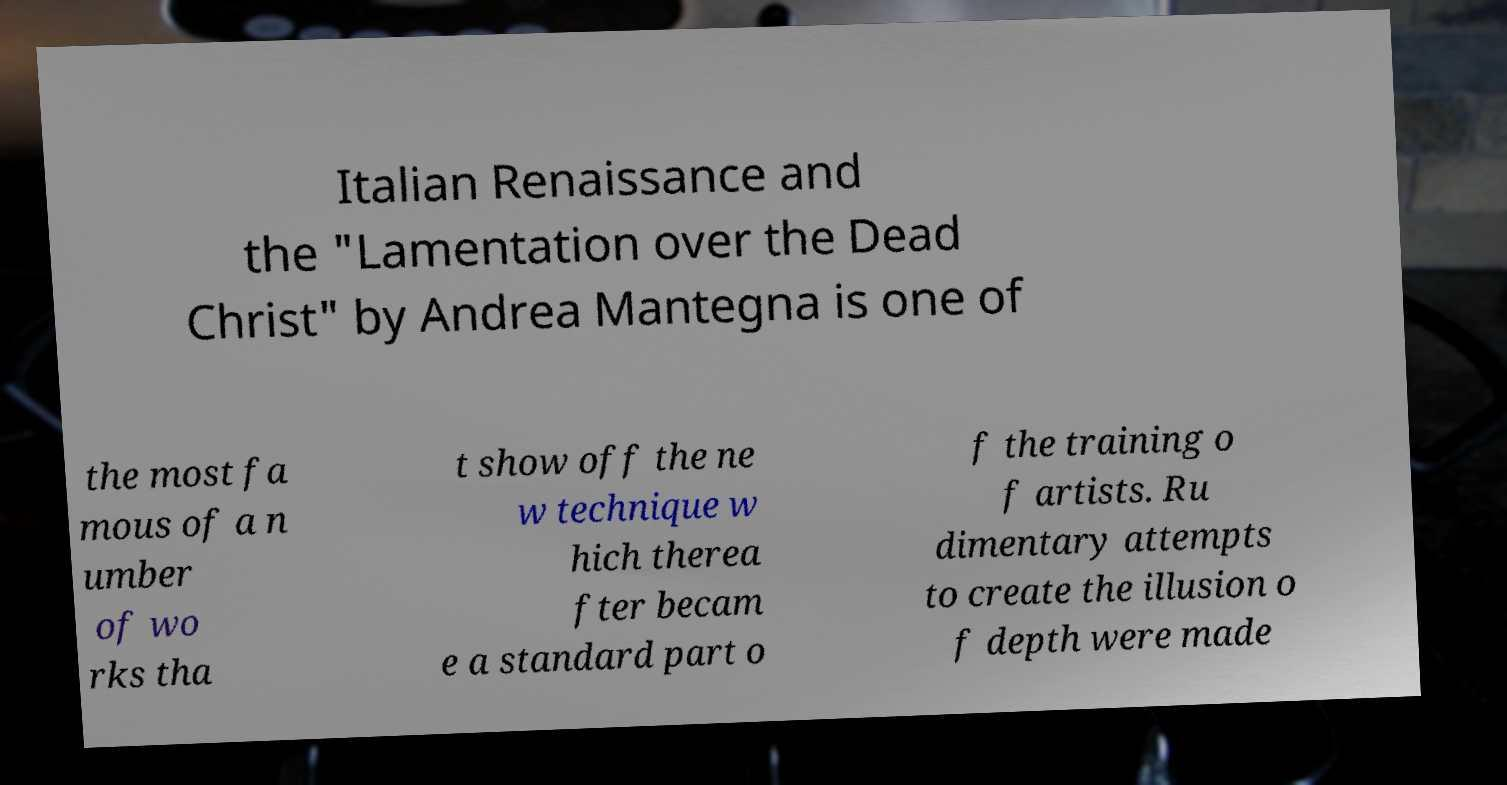Can you read and provide the text displayed in the image?This photo seems to have some interesting text. Can you extract and type it out for me? Italian Renaissance and the "Lamentation over the Dead Christ" by Andrea Mantegna is one of the most fa mous of a n umber of wo rks tha t show off the ne w technique w hich therea fter becam e a standard part o f the training o f artists. Ru dimentary attempts to create the illusion o f depth were made 